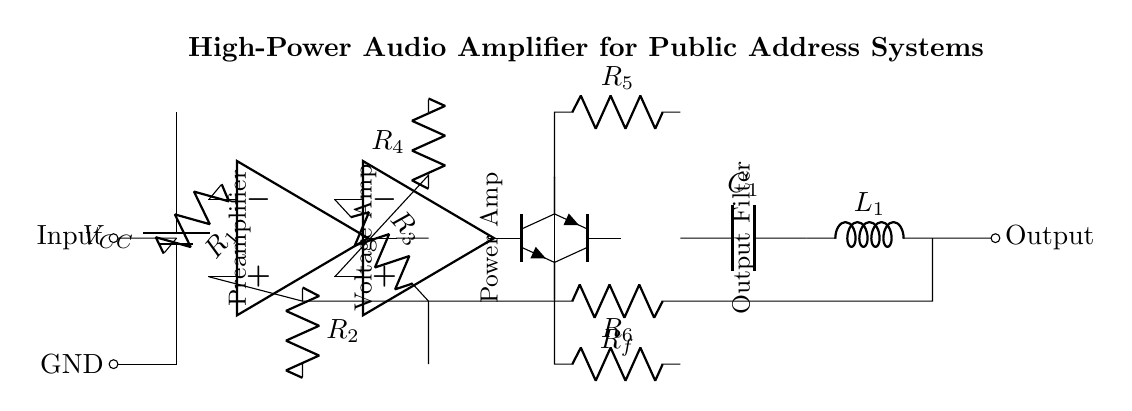What is the voltage supply for this circuit? The voltage supply is indicated by the battery symbol labeled "V_CC". It represents the voltage provided to the circuit components, which is necessary for their operation.
Answer: V_CC What type of amplifier is used in the input stage? The input stage uses an operational amplifier, as denoted by the op amp symbol. This type of amplifier is designed to amplify small signals while maintaining high input impedance.
Answer: Operational amplifier How many resistors are present in the circuit? By examining the circuit diagram, there are six labeled resistors: R1, R2, R3, R4, R5, and R6. Each resistor has a different function within the amplifier stages, contributing to the overall performance of the circuit.
Answer: Six What connects the output of the power amplification stage to the output filter? The output of the power amplification stage connects to a capacitor, labeled "C1", marking the transition to the output filter stage. This component plays a crucial role in filtering the amplified audio signal.
Answer: Capacitor What is the role of R_f in the feedback loop of the circuit? R_f, labeled as the feedback resistor, connects the output of the output filter back to the input of the voltage amplification stage. This feedback helps stabilize the circuit and control the gain, ensuring that the output signal is accurately amplified.
Answer: Stabilizes gain Which two types of transistors are used in the power amplification stage? The power amplification stage includes two transistors, one NPN transistor (labeled Q1) and one PNP transistor (labeled Q2). These transistor types work together to provide the necessary power amplification for the audio signal in the circuit.
Answer: NPN and PNP 